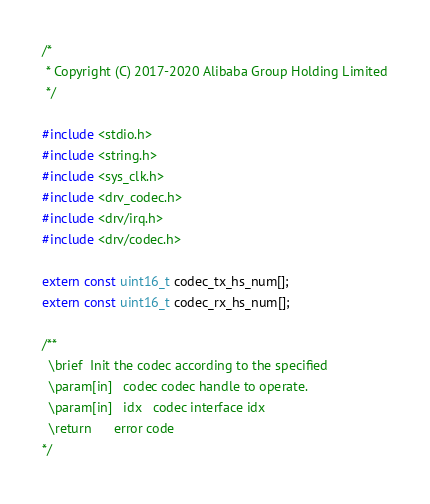<code> <loc_0><loc_0><loc_500><loc_500><_C_>/*
 * Copyright (C) 2017-2020 Alibaba Group Holding Limited
 */

#include <stdio.h>
#include <string.h>
#include <sys_clk.h>
#include <drv_codec.h>
#include <drv/irq.h>
#include <drv/codec.h>

extern const uint16_t codec_tx_hs_num[];
extern const uint16_t codec_rx_hs_num[];

/**
  \brief  Init the codec according to the specified
  \param[in]   codec codec handle to operate.
  \param[in]   idx   codec interface idx
  \return      error code
*/</code> 